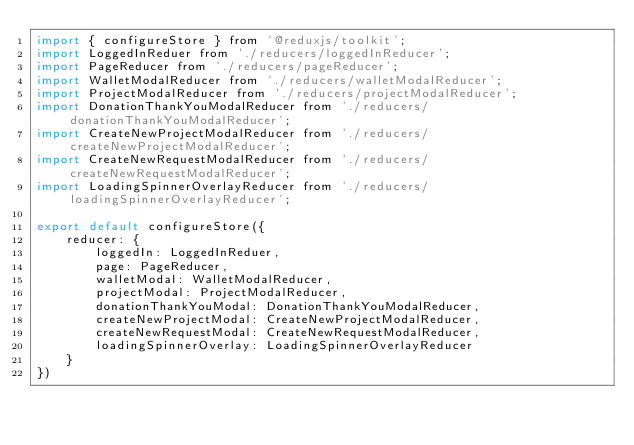<code> <loc_0><loc_0><loc_500><loc_500><_JavaScript_>import { configureStore } from '@reduxjs/toolkit';
import LoggedInReduer from './reducers/loggedInReducer';
import PageReducer from './reducers/pageReducer';
import WalletModalReducer from './reducers/walletModalReducer';
import ProjectModalReducer from './reducers/projectModalReducer';
import DonationThankYouModalReducer from './reducers/donationThankYouModalReducer';
import CreateNewProjectModalReducer from './reducers/createNewProjectModalReducer';
import CreateNewRequestModalReducer from './reducers/createNewRequestModalReducer';
import LoadingSpinnerOverlayReducer from './reducers/loadingSpinnerOverlayReducer';

export default configureStore({
    reducer: {
        loggedIn: LoggedInReduer,
        page: PageReducer,
        walletModal: WalletModalReducer,
        projectModal: ProjectModalReducer,
        donationThankYouModal: DonationThankYouModalReducer,
        createNewProjectModal: CreateNewProjectModalReducer,
        createNewRequestModal: CreateNewRequestModalReducer,
        loadingSpinnerOverlay: LoadingSpinnerOverlayReducer
    }
})</code> 